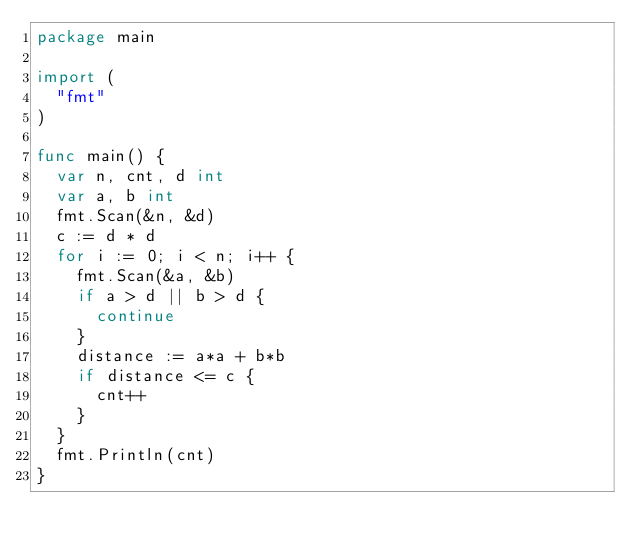Convert code to text. <code><loc_0><loc_0><loc_500><loc_500><_Go_>package main

import (
	"fmt"
)

func main() {
	var n, cnt, d int
	var a, b int
	fmt.Scan(&n, &d)
	c := d * d
	for i := 0; i < n; i++ {
		fmt.Scan(&a, &b)
		if a > d || b > d {
			continue
		}
		distance := a*a + b*b
		if distance <= c {
			cnt++
		}
	}
	fmt.Println(cnt)
}
</code> 